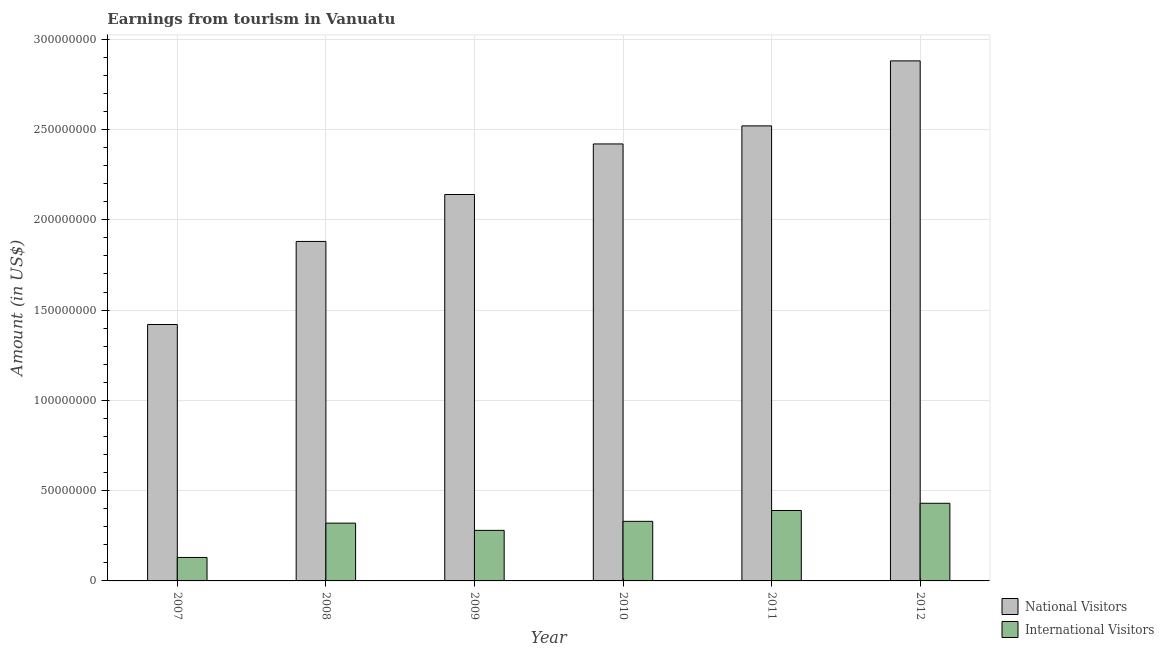How many groups of bars are there?
Your answer should be very brief. 6. Are the number of bars on each tick of the X-axis equal?
Give a very brief answer. Yes. How many bars are there on the 4th tick from the left?
Make the answer very short. 2. What is the label of the 6th group of bars from the left?
Your answer should be very brief. 2012. What is the amount earned from international visitors in 2009?
Offer a terse response. 2.80e+07. Across all years, what is the maximum amount earned from national visitors?
Make the answer very short. 2.88e+08. Across all years, what is the minimum amount earned from national visitors?
Your answer should be compact. 1.42e+08. In which year was the amount earned from international visitors maximum?
Provide a succinct answer. 2012. What is the total amount earned from national visitors in the graph?
Your answer should be very brief. 1.33e+09. What is the difference between the amount earned from international visitors in 2008 and that in 2011?
Provide a short and direct response. -7.00e+06. What is the difference between the amount earned from international visitors in 2010 and the amount earned from national visitors in 2007?
Give a very brief answer. 2.00e+07. What is the average amount earned from national visitors per year?
Provide a succinct answer. 2.21e+08. In how many years, is the amount earned from national visitors greater than 140000000 US$?
Offer a very short reply. 6. What is the ratio of the amount earned from international visitors in 2009 to that in 2011?
Make the answer very short. 0.72. Is the amount earned from international visitors in 2009 less than that in 2011?
Your answer should be very brief. Yes. Is the difference between the amount earned from national visitors in 2011 and 2012 greater than the difference between the amount earned from international visitors in 2011 and 2012?
Keep it short and to the point. No. What is the difference between the highest and the second highest amount earned from national visitors?
Your response must be concise. 3.60e+07. What is the difference between the highest and the lowest amount earned from international visitors?
Your answer should be very brief. 3.00e+07. In how many years, is the amount earned from national visitors greater than the average amount earned from national visitors taken over all years?
Offer a terse response. 3. Is the sum of the amount earned from international visitors in 2010 and 2011 greater than the maximum amount earned from national visitors across all years?
Provide a succinct answer. Yes. What does the 1st bar from the left in 2011 represents?
Provide a short and direct response. National Visitors. What does the 2nd bar from the right in 2012 represents?
Provide a succinct answer. National Visitors. How many bars are there?
Your answer should be compact. 12. Does the graph contain grids?
Make the answer very short. Yes. How are the legend labels stacked?
Give a very brief answer. Vertical. What is the title of the graph?
Offer a very short reply. Earnings from tourism in Vanuatu. Does "Current education expenditure" appear as one of the legend labels in the graph?
Offer a very short reply. No. What is the label or title of the X-axis?
Ensure brevity in your answer.  Year. What is the label or title of the Y-axis?
Offer a very short reply. Amount (in US$). What is the Amount (in US$) in National Visitors in 2007?
Your answer should be compact. 1.42e+08. What is the Amount (in US$) of International Visitors in 2007?
Your answer should be very brief. 1.30e+07. What is the Amount (in US$) in National Visitors in 2008?
Your answer should be compact. 1.88e+08. What is the Amount (in US$) in International Visitors in 2008?
Provide a succinct answer. 3.20e+07. What is the Amount (in US$) of National Visitors in 2009?
Give a very brief answer. 2.14e+08. What is the Amount (in US$) of International Visitors in 2009?
Your response must be concise. 2.80e+07. What is the Amount (in US$) in National Visitors in 2010?
Keep it short and to the point. 2.42e+08. What is the Amount (in US$) in International Visitors in 2010?
Your answer should be compact. 3.30e+07. What is the Amount (in US$) of National Visitors in 2011?
Offer a very short reply. 2.52e+08. What is the Amount (in US$) of International Visitors in 2011?
Provide a succinct answer. 3.90e+07. What is the Amount (in US$) of National Visitors in 2012?
Your answer should be compact. 2.88e+08. What is the Amount (in US$) of International Visitors in 2012?
Make the answer very short. 4.30e+07. Across all years, what is the maximum Amount (in US$) of National Visitors?
Provide a succinct answer. 2.88e+08. Across all years, what is the maximum Amount (in US$) of International Visitors?
Keep it short and to the point. 4.30e+07. Across all years, what is the minimum Amount (in US$) in National Visitors?
Your answer should be very brief. 1.42e+08. Across all years, what is the minimum Amount (in US$) of International Visitors?
Ensure brevity in your answer.  1.30e+07. What is the total Amount (in US$) in National Visitors in the graph?
Give a very brief answer. 1.33e+09. What is the total Amount (in US$) of International Visitors in the graph?
Your answer should be compact. 1.88e+08. What is the difference between the Amount (in US$) of National Visitors in 2007 and that in 2008?
Your answer should be very brief. -4.60e+07. What is the difference between the Amount (in US$) in International Visitors in 2007 and that in 2008?
Provide a short and direct response. -1.90e+07. What is the difference between the Amount (in US$) of National Visitors in 2007 and that in 2009?
Ensure brevity in your answer.  -7.20e+07. What is the difference between the Amount (in US$) of International Visitors in 2007 and that in 2009?
Your answer should be compact. -1.50e+07. What is the difference between the Amount (in US$) of National Visitors in 2007 and that in 2010?
Offer a terse response. -1.00e+08. What is the difference between the Amount (in US$) in International Visitors in 2007 and that in 2010?
Offer a very short reply. -2.00e+07. What is the difference between the Amount (in US$) in National Visitors in 2007 and that in 2011?
Keep it short and to the point. -1.10e+08. What is the difference between the Amount (in US$) in International Visitors in 2007 and that in 2011?
Provide a succinct answer. -2.60e+07. What is the difference between the Amount (in US$) in National Visitors in 2007 and that in 2012?
Your answer should be very brief. -1.46e+08. What is the difference between the Amount (in US$) of International Visitors in 2007 and that in 2012?
Offer a very short reply. -3.00e+07. What is the difference between the Amount (in US$) in National Visitors in 2008 and that in 2009?
Your response must be concise. -2.60e+07. What is the difference between the Amount (in US$) in International Visitors in 2008 and that in 2009?
Your answer should be very brief. 4.00e+06. What is the difference between the Amount (in US$) of National Visitors in 2008 and that in 2010?
Your response must be concise. -5.40e+07. What is the difference between the Amount (in US$) in International Visitors in 2008 and that in 2010?
Offer a very short reply. -1.00e+06. What is the difference between the Amount (in US$) of National Visitors in 2008 and that in 2011?
Offer a very short reply. -6.40e+07. What is the difference between the Amount (in US$) in International Visitors in 2008 and that in 2011?
Give a very brief answer. -7.00e+06. What is the difference between the Amount (in US$) in National Visitors in 2008 and that in 2012?
Give a very brief answer. -1.00e+08. What is the difference between the Amount (in US$) in International Visitors in 2008 and that in 2012?
Your response must be concise. -1.10e+07. What is the difference between the Amount (in US$) of National Visitors in 2009 and that in 2010?
Your response must be concise. -2.80e+07. What is the difference between the Amount (in US$) of International Visitors in 2009 and that in 2010?
Keep it short and to the point. -5.00e+06. What is the difference between the Amount (in US$) of National Visitors in 2009 and that in 2011?
Ensure brevity in your answer.  -3.80e+07. What is the difference between the Amount (in US$) of International Visitors in 2009 and that in 2011?
Give a very brief answer. -1.10e+07. What is the difference between the Amount (in US$) of National Visitors in 2009 and that in 2012?
Your response must be concise. -7.40e+07. What is the difference between the Amount (in US$) of International Visitors in 2009 and that in 2012?
Your answer should be compact. -1.50e+07. What is the difference between the Amount (in US$) in National Visitors in 2010 and that in 2011?
Keep it short and to the point. -1.00e+07. What is the difference between the Amount (in US$) of International Visitors in 2010 and that in 2011?
Provide a succinct answer. -6.00e+06. What is the difference between the Amount (in US$) of National Visitors in 2010 and that in 2012?
Provide a succinct answer. -4.60e+07. What is the difference between the Amount (in US$) of International Visitors in 2010 and that in 2012?
Give a very brief answer. -1.00e+07. What is the difference between the Amount (in US$) of National Visitors in 2011 and that in 2012?
Provide a succinct answer. -3.60e+07. What is the difference between the Amount (in US$) of International Visitors in 2011 and that in 2012?
Keep it short and to the point. -4.00e+06. What is the difference between the Amount (in US$) in National Visitors in 2007 and the Amount (in US$) in International Visitors in 2008?
Your answer should be very brief. 1.10e+08. What is the difference between the Amount (in US$) in National Visitors in 2007 and the Amount (in US$) in International Visitors in 2009?
Give a very brief answer. 1.14e+08. What is the difference between the Amount (in US$) in National Visitors in 2007 and the Amount (in US$) in International Visitors in 2010?
Provide a short and direct response. 1.09e+08. What is the difference between the Amount (in US$) of National Visitors in 2007 and the Amount (in US$) of International Visitors in 2011?
Offer a terse response. 1.03e+08. What is the difference between the Amount (in US$) of National Visitors in 2007 and the Amount (in US$) of International Visitors in 2012?
Your response must be concise. 9.90e+07. What is the difference between the Amount (in US$) of National Visitors in 2008 and the Amount (in US$) of International Visitors in 2009?
Offer a terse response. 1.60e+08. What is the difference between the Amount (in US$) of National Visitors in 2008 and the Amount (in US$) of International Visitors in 2010?
Provide a short and direct response. 1.55e+08. What is the difference between the Amount (in US$) of National Visitors in 2008 and the Amount (in US$) of International Visitors in 2011?
Make the answer very short. 1.49e+08. What is the difference between the Amount (in US$) in National Visitors in 2008 and the Amount (in US$) in International Visitors in 2012?
Provide a short and direct response. 1.45e+08. What is the difference between the Amount (in US$) of National Visitors in 2009 and the Amount (in US$) of International Visitors in 2010?
Offer a very short reply. 1.81e+08. What is the difference between the Amount (in US$) in National Visitors in 2009 and the Amount (in US$) in International Visitors in 2011?
Provide a succinct answer. 1.75e+08. What is the difference between the Amount (in US$) of National Visitors in 2009 and the Amount (in US$) of International Visitors in 2012?
Your response must be concise. 1.71e+08. What is the difference between the Amount (in US$) of National Visitors in 2010 and the Amount (in US$) of International Visitors in 2011?
Your answer should be compact. 2.03e+08. What is the difference between the Amount (in US$) in National Visitors in 2010 and the Amount (in US$) in International Visitors in 2012?
Offer a very short reply. 1.99e+08. What is the difference between the Amount (in US$) in National Visitors in 2011 and the Amount (in US$) in International Visitors in 2012?
Provide a short and direct response. 2.09e+08. What is the average Amount (in US$) in National Visitors per year?
Your answer should be very brief. 2.21e+08. What is the average Amount (in US$) in International Visitors per year?
Your answer should be very brief. 3.13e+07. In the year 2007, what is the difference between the Amount (in US$) in National Visitors and Amount (in US$) in International Visitors?
Keep it short and to the point. 1.29e+08. In the year 2008, what is the difference between the Amount (in US$) in National Visitors and Amount (in US$) in International Visitors?
Make the answer very short. 1.56e+08. In the year 2009, what is the difference between the Amount (in US$) in National Visitors and Amount (in US$) in International Visitors?
Provide a short and direct response. 1.86e+08. In the year 2010, what is the difference between the Amount (in US$) of National Visitors and Amount (in US$) of International Visitors?
Your answer should be compact. 2.09e+08. In the year 2011, what is the difference between the Amount (in US$) of National Visitors and Amount (in US$) of International Visitors?
Provide a succinct answer. 2.13e+08. In the year 2012, what is the difference between the Amount (in US$) in National Visitors and Amount (in US$) in International Visitors?
Offer a very short reply. 2.45e+08. What is the ratio of the Amount (in US$) in National Visitors in 2007 to that in 2008?
Give a very brief answer. 0.76. What is the ratio of the Amount (in US$) of International Visitors in 2007 to that in 2008?
Make the answer very short. 0.41. What is the ratio of the Amount (in US$) of National Visitors in 2007 to that in 2009?
Your answer should be compact. 0.66. What is the ratio of the Amount (in US$) in International Visitors in 2007 to that in 2009?
Ensure brevity in your answer.  0.46. What is the ratio of the Amount (in US$) of National Visitors in 2007 to that in 2010?
Your answer should be compact. 0.59. What is the ratio of the Amount (in US$) of International Visitors in 2007 to that in 2010?
Provide a succinct answer. 0.39. What is the ratio of the Amount (in US$) in National Visitors in 2007 to that in 2011?
Provide a succinct answer. 0.56. What is the ratio of the Amount (in US$) in National Visitors in 2007 to that in 2012?
Keep it short and to the point. 0.49. What is the ratio of the Amount (in US$) of International Visitors in 2007 to that in 2012?
Ensure brevity in your answer.  0.3. What is the ratio of the Amount (in US$) in National Visitors in 2008 to that in 2009?
Offer a very short reply. 0.88. What is the ratio of the Amount (in US$) of International Visitors in 2008 to that in 2009?
Make the answer very short. 1.14. What is the ratio of the Amount (in US$) of National Visitors in 2008 to that in 2010?
Ensure brevity in your answer.  0.78. What is the ratio of the Amount (in US$) in International Visitors in 2008 to that in 2010?
Your answer should be very brief. 0.97. What is the ratio of the Amount (in US$) of National Visitors in 2008 to that in 2011?
Give a very brief answer. 0.75. What is the ratio of the Amount (in US$) of International Visitors in 2008 to that in 2011?
Offer a very short reply. 0.82. What is the ratio of the Amount (in US$) of National Visitors in 2008 to that in 2012?
Your answer should be compact. 0.65. What is the ratio of the Amount (in US$) in International Visitors in 2008 to that in 2012?
Make the answer very short. 0.74. What is the ratio of the Amount (in US$) in National Visitors in 2009 to that in 2010?
Provide a succinct answer. 0.88. What is the ratio of the Amount (in US$) of International Visitors in 2009 to that in 2010?
Keep it short and to the point. 0.85. What is the ratio of the Amount (in US$) in National Visitors in 2009 to that in 2011?
Offer a very short reply. 0.85. What is the ratio of the Amount (in US$) of International Visitors in 2009 to that in 2011?
Your answer should be very brief. 0.72. What is the ratio of the Amount (in US$) of National Visitors in 2009 to that in 2012?
Your response must be concise. 0.74. What is the ratio of the Amount (in US$) in International Visitors in 2009 to that in 2012?
Give a very brief answer. 0.65. What is the ratio of the Amount (in US$) of National Visitors in 2010 to that in 2011?
Offer a terse response. 0.96. What is the ratio of the Amount (in US$) of International Visitors in 2010 to that in 2011?
Your response must be concise. 0.85. What is the ratio of the Amount (in US$) of National Visitors in 2010 to that in 2012?
Give a very brief answer. 0.84. What is the ratio of the Amount (in US$) in International Visitors in 2010 to that in 2012?
Provide a succinct answer. 0.77. What is the ratio of the Amount (in US$) of National Visitors in 2011 to that in 2012?
Your answer should be compact. 0.88. What is the ratio of the Amount (in US$) in International Visitors in 2011 to that in 2012?
Provide a short and direct response. 0.91. What is the difference between the highest and the second highest Amount (in US$) of National Visitors?
Provide a succinct answer. 3.60e+07. What is the difference between the highest and the second highest Amount (in US$) of International Visitors?
Your response must be concise. 4.00e+06. What is the difference between the highest and the lowest Amount (in US$) of National Visitors?
Offer a terse response. 1.46e+08. What is the difference between the highest and the lowest Amount (in US$) of International Visitors?
Your response must be concise. 3.00e+07. 